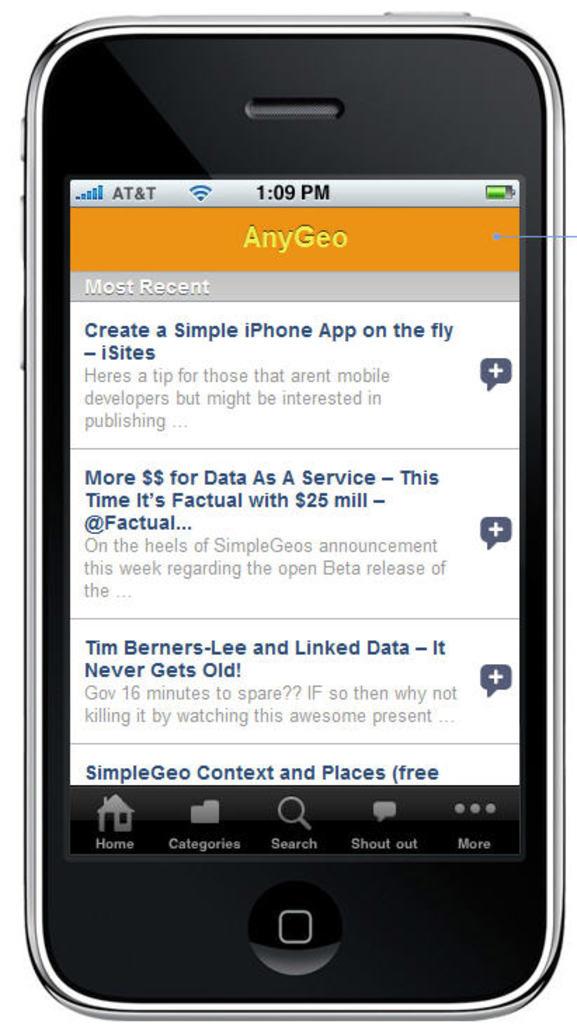What carrier is this iphone with?
Your answer should be very brief. At&t. What time is on the phone?
Make the answer very short. 1:09. 